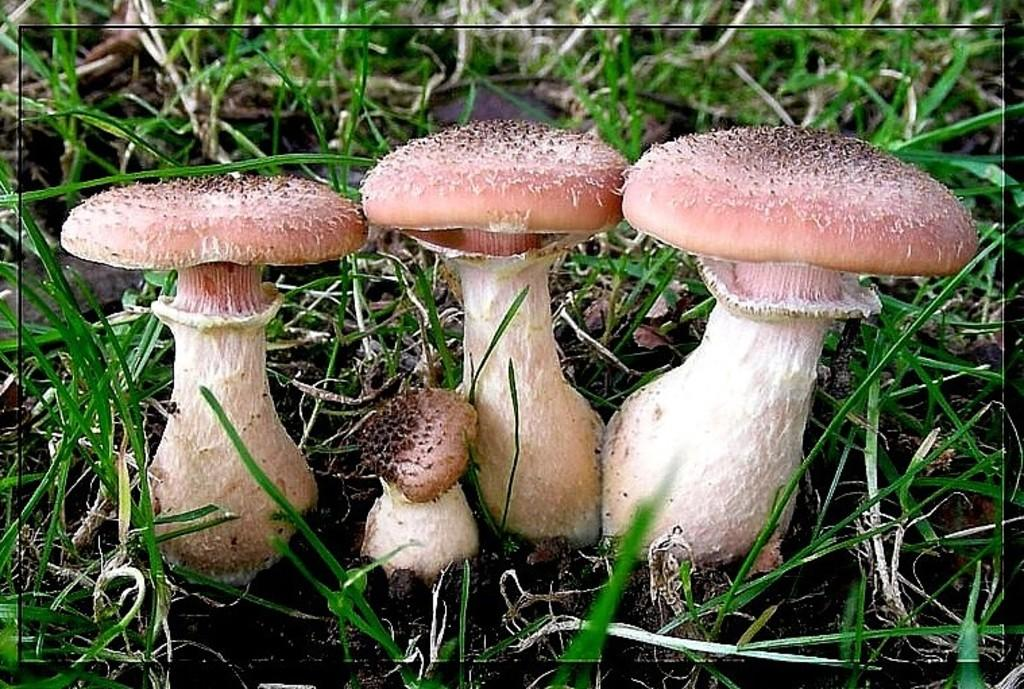What type of vegetation can be seen in the image? There are mushrooms and grass in the image. Where are the mushrooms and grass located? Both the mushrooms and grass are on the ground in the image. What is the current rate on the person's account in the image? There is no person or account present in the image; it features mushrooms and grass on the ground. 